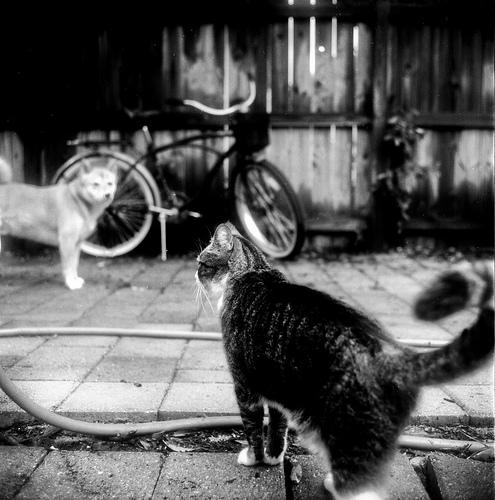Question: what material is the fence?
Choices:
A. Plastic.
B. Cast Iron.
C. Steel.
D. Wood.
Answer with the letter. Answer: D Question: how many wheels does the bike have?
Choices:
A. 1.
B. 4.
C. 2.
D. 3.
Answer with the letter. Answer: C Question: what is next to the fence?
Choices:
A. Tree.
B. A bike.
C. A flower.
D. The grass.
Answer with the letter. Answer: B 